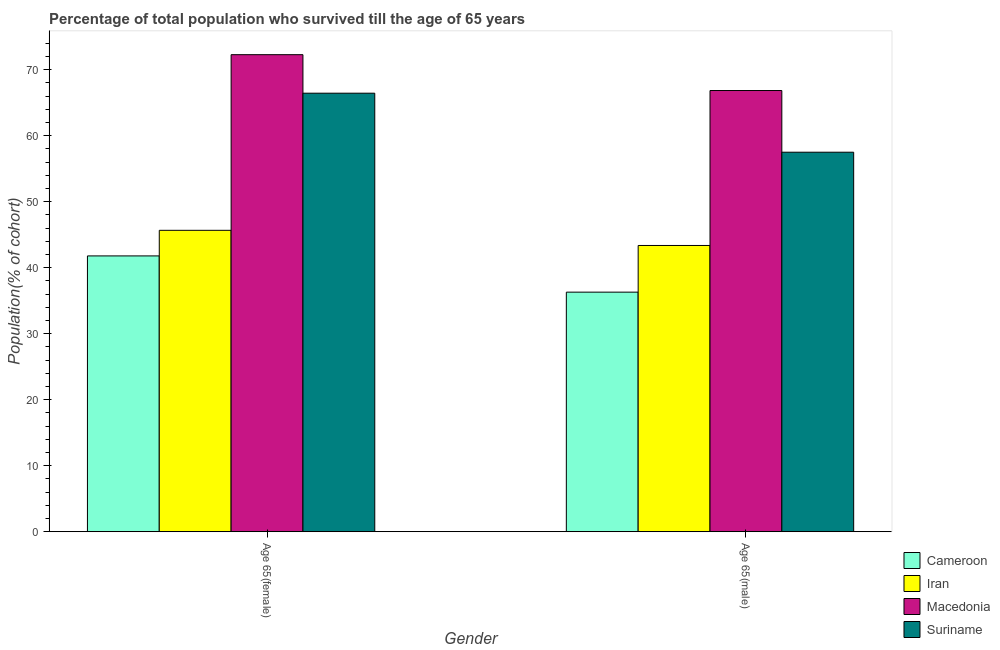How many different coloured bars are there?
Make the answer very short. 4. How many groups of bars are there?
Offer a very short reply. 2. How many bars are there on the 1st tick from the left?
Provide a short and direct response. 4. What is the label of the 2nd group of bars from the left?
Offer a very short reply. Age 65(male). What is the percentage of male population who survived till age of 65 in Iran?
Make the answer very short. 43.36. Across all countries, what is the maximum percentage of female population who survived till age of 65?
Your answer should be compact. 72.27. Across all countries, what is the minimum percentage of female population who survived till age of 65?
Your response must be concise. 41.78. In which country was the percentage of male population who survived till age of 65 maximum?
Keep it short and to the point. Macedonia. In which country was the percentage of male population who survived till age of 65 minimum?
Your answer should be compact. Cameroon. What is the total percentage of male population who survived till age of 65 in the graph?
Offer a very short reply. 203.98. What is the difference between the percentage of female population who survived till age of 65 in Cameroon and that in Macedonia?
Your answer should be compact. -30.49. What is the difference between the percentage of female population who survived till age of 65 in Iran and the percentage of male population who survived till age of 65 in Macedonia?
Your answer should be compact. -21.18. What is the average percentage of female population who survived till age of 65 per country?
Your answer should be compact. 56.54. What is the difference between the percentage of female population who survived till age of 65 and percentage of male population who survived till age of 65 in Macedonia?
Ensure brevity in your answer.  5.43. What is the ratio of the percentage of female population who survived till age of 65 in Cameroon to that in Suriname?
Give a very brief answer. 0.63. Is the percentage of male population who survived till age of 65 in Macedonia less than that in Iran?
Provide a succinct answer. No. What does the 4th bar from the left in Age 65(male) represents?
Keep it short and to the point. Suriname. What does the 2nd bar from the right in Age 65(female) represents?
Your answer should be compact. Macedonia. How many bars are there?
Your answer should be very brief. 8. Are all the bars in the graph horizontal?
Keep it short and to the point. No. How many countries are there in the graph?
Offer a very short reply. 4. Does the graph contain any zero values?
Ensure brevity in your answer.  No. Where does the legend appear in the graph?
Provide a short and direct response. Bottom right. How many legend labels are there?
Your answer should be compact. 4. How are the legend labels stacked?
Your answer should be very brief. Vertical. What is the title of the graph?
Your answer should be compact. Percentage of total population who survived till the age of 65 years. What is the label or title of the X-axis?
Provide a short and direct response. Gender. What is the label or title of the Y-axis?
Provide a succinct answer. Population(% of cohort). What is the Population(% of cohort) of Cameroon in Age 65(female)?
Keep it short and to the point. 41.78. What is the Population(% of cohort) in Iran in Age 65(female)?
Offer a very short reply. 45.66. What is the Population(% of cohort) in Macedonia in Age 65(female)?
Your answer should be compact. 72.27. What is the Population(% of cohort) of Suriname in Age 65(female)?
Your response must be concise. 66.43. What is the Population(% of cohort) in Cameroon in Age 65(male)?
Give a very brief answer. 36.29. What is the Population(% of cohort) of Iran in Age 65(male)?
Ensure brevity in your answer.  43.36. What is the Population(% of cohort) of Macedonia in Age 65(male)?
Offer a terse response. 66.84. What is the Population(% of cohort) in Suriname in Age 65(male)?
Keep it short and to the point. 57.49. Across all Gender, what is the maximum Population(% of cohort) of Cameroon?
Offer a very short reply. 41.78. Across all Gender, what is the maximum Population(% of cohort) in Iran?
Provide a succinct answer. 45.66. Across all Gender, what is the maximum Population(% of cohort) of Macedonia?
Your response must be concise. 72.27. Across all Gender, what is the maximum Population(% of cohort) of Suriname?
Provide a succinct answer. 66.43. Across all Gender, what is the minimum Population(% of cohort) of Cameroon?
Your answer should be compact. 36.29. Across all Gender, what is the minimum Population(% of cohort) of Iran?
Offer a very short reply. 43.36. Across all Gender, what is the minimum Population(% of cohort) in Macedonia?
Your answer should be very brief. 66.84. Across all Gender, what is the minimum Population(% of cohort) of Suriname?
Your response must be concise. 57.49. What is the total Population(% of cohort) in Cameroon in the graph?
Provide a short and direct response. 78.07. What is the total Population(% of cohort) of Iran in the graph?
Your answer should be compact. 89.02. What is the total Population(% of cohort) of Macedonia in the graph?
Give a very brief answer. 139.1. What is the total Population(% of cohort) of Suriname in the graph?
Make the answer very short. 123.92. What is the difference between the Population(% of cohort) in Cameroon in Age 65(female) and that in Age 65(male)?
Provide a succinct answer. 5.49. What is the difference between the Population(% of cohort) in Iran in Age 65(female) and that in Age 65(male)?
Offer a very short reply. 2.3. What is the difference between the Population(% of cohort) in Macedonia in Age 65(female) and that in Age 65(male)?
Make the answer very short. 5.43. What is the difference between the Population(% of cohort) in Suriname in Age 65(female) and that in Age 65(male)?
Offer a terse response. 8.94. What is the difference between the Population(% of cohort) in Cameroon in Age 65(female) and the Population(% of cohort) in Iran in Age 65(male)?
Provide a short and direct response. -1.58. What is the difference between the Population(% of cohort) in Cameroon in Age 65(female) and the Population(% of cohort) in Macedonia in Age 65(male)?
Your answer should be very brief. -25.05. What is the difference between the Population(% of cohort) of Cameroon in Age 65(female) and the Population(% of cohort) of Suriname in Age 65(male)?
Provide a short and direct response. -15.71. What is the difference between the Population(% of cohort) of Iran in Age 65(female) and the Population(% of cohort) of Macedonia in Age 65(male)?
Your response must be concise. -21.18. What is the difference between the Population(% of cohort) of Iran in Age 65(female) and the Population(% of cohort) of Suriname in Age 65(male)?
Keep it short and to the point. -11.83. What is the difference between the Population(% of cohort) in Macedonia in Age 65(female) and the Population(% of cohort) in Suriname in Age 65(male)?
Your response must be concise. 14.78. What is the average Population(% of cohort) in Cameroon per Gender?
Make the answer very short. 39.04. What is the average Population(% of cohort) in Iran per Gender?
Provide a succinct answer. 44.51. What is the average Population(% of cohort) in Macedonia per Gender?
Ensure brevity in your answer.  69.55. What is the average Population(% of cohort) of Suriname per Gender?
Offer a terse response. 61.96. What is the difference between the Population(% of cohort) in Cameroon and Population(% of cohort) in Iran in Age 65(female)?
Ensure brevity in your answer.  -3.88. What is the difference between the Population(% of cohort) in Cameroon and Population(% of cohort) in Macedonia in Age 65(female)?
Your answer should be very brief. -30.49. What is the difference between the Population(% of cohort) in Cameroon and Population(% of cohort) in Suriname in Age 65(female)?
Your answer should be very brief. -24.65. What is the difference between the Population(% of cohort) in Iran and Population(% of cohort) in Macedonia in Age 65(female)?
Make the answer very short. -26.61. What is the difference between the Population(% of cohort) in Iran and Population(% of cohort) in Suriname in Age 65(female)?
Offer a terse response. -20.77. What is the difference between the Population(% of cohort) of Macedonia and Population(% of cohort) of Suriname in Age 65(female)?
Keep it short and to the point. 5.84. What is the difference between the Population(% of cohort) of Cameroon and Population(% of cohort) of Iran in Age 65(male)?
Give a very brief answer. -7.07. What is the difference between the Population(% of cohort) of Cameroon and Population(% of cohort) of Macedonia in Age 65(male)?
Ensure brevity in your answer.  -30.54. What is the difference between the Population(% of cohort) in Cameroon and Population(% of cohort) in Suriname in Age 65(male)?
Offer a terse response. -21.2. What is the difference between the Population(% of cohort) in Iran and Population(% of cohort) in Macedonia in Age 65(male)?
Offer a terse response. -23.47. What is the difference between the Population(% of cohort) of Iran and Population(% of cohort) of Suriname in Age 65(male)?
Offer a very short reply. -14.13. What is the difference between the Population(% of cohort) of Macedonia and Population(% of cohort) of Suriname in Age 65(male)?
Offer a terse response. 9.35. What is the ratio of the Population(% of cohort) of Cameroon in Age 65(female) to that in Age 65(male)?
Provide a short and direct response. 1.15. What is the ratio of the Population(% of cohort) of Iran in Age 65(female) to that in Age 65(male)?
Provide a short and direct response. 1.05. What is the ratio of the Population(% of cohort) in Macedonia in Age 65(female) to that in Age 65(male)?
Provide a short and direct response. 1.08. What is the ratio of the Population(% of cohort) in Suriname in Age 65(female) to that in Age 65(male)?
Your response must be concise. 1.16. What is the difference between the highest and the second highest Population(% of cohort) in Cameroon?
Your answer should be compact. 5.49. What is the difference between the highest and the second highest Population(% of cohort) of Iran?
Make the answer very short. 2.3. What is the difference between the highest and the second highest Population(% of cohort) in Macedonia?
Make the answer very short. 5.43. What is the difference between the highest and the second highest Population(% of cohort) of Suriname?
Provide a succinct answer. 8.94. What is the difference between the highest and the lowest Population(% of cohort) in Cameroon?
Provide a short and direct response. 5.49. What is the difference between the highest and the lowest Population(% of cohort) of Iran?
Your answer should be very brief. 2.3. What is the difference between the highest and the lowest Population(% of cohort) in Macedonia?
Provide a succinct answer. 5.43. What is the difference between the highest and the lowest Population(% of cohort) in Suriname?
Your response must be concise. 8.94. 